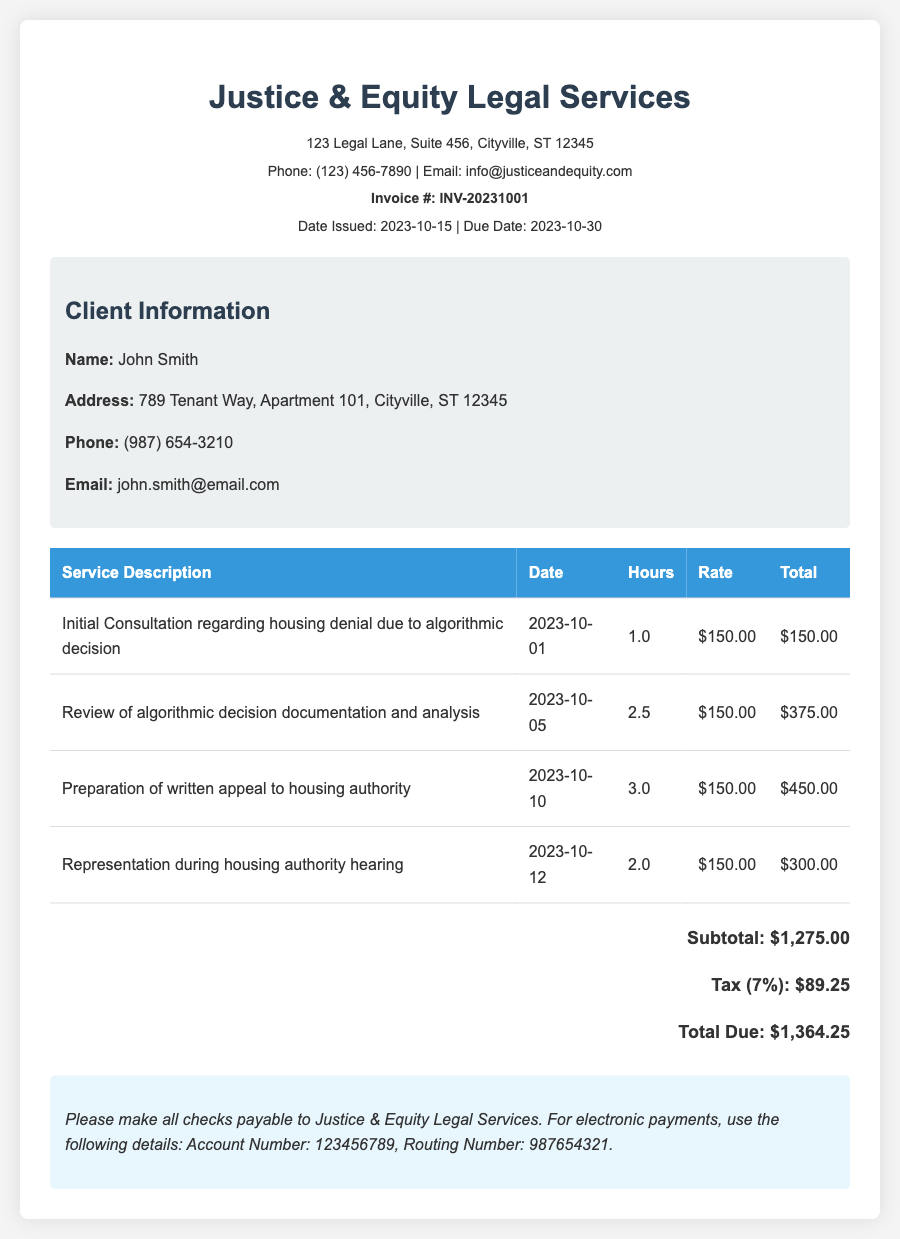What is the total amount due? The total amount due is shown at the bottom of the invoice after adding the subtotal and tax, which is $1,275.00 + $89.25.
Answer: $1,364.25 Who is the client? The client's name is listed in the client information section of the document.
Answer: John Smith What is the hourly rate for legal services? The hourly rate is specified in the service details of the invoice.
Answer: $150.00 When was the initial consultation held? The date of the initial consultation is included in the service description table.
Answer: 2023-10-01 How many hours were billed for the review of documentation? The number of hours for the review of documentation is provided in the service details.
Answer: 2.5 What percentage is the tax applied on the subtotal? The tax percentage is specified in the total calculations section of the invoice.
Answer: 7% What service was provided on 2023-10-10? The service provided on that date is included in the service description table.
Answer: Preparation of written appeal to housing authority How much was charged for representation during the housing hearing? The cost for that service is calculated in the service details of the invoice.
Answer: $300.00 What is the due date for the invoice? The due date is listed near the top of the invoice following the date issued.
Answer: 2023-10-30 